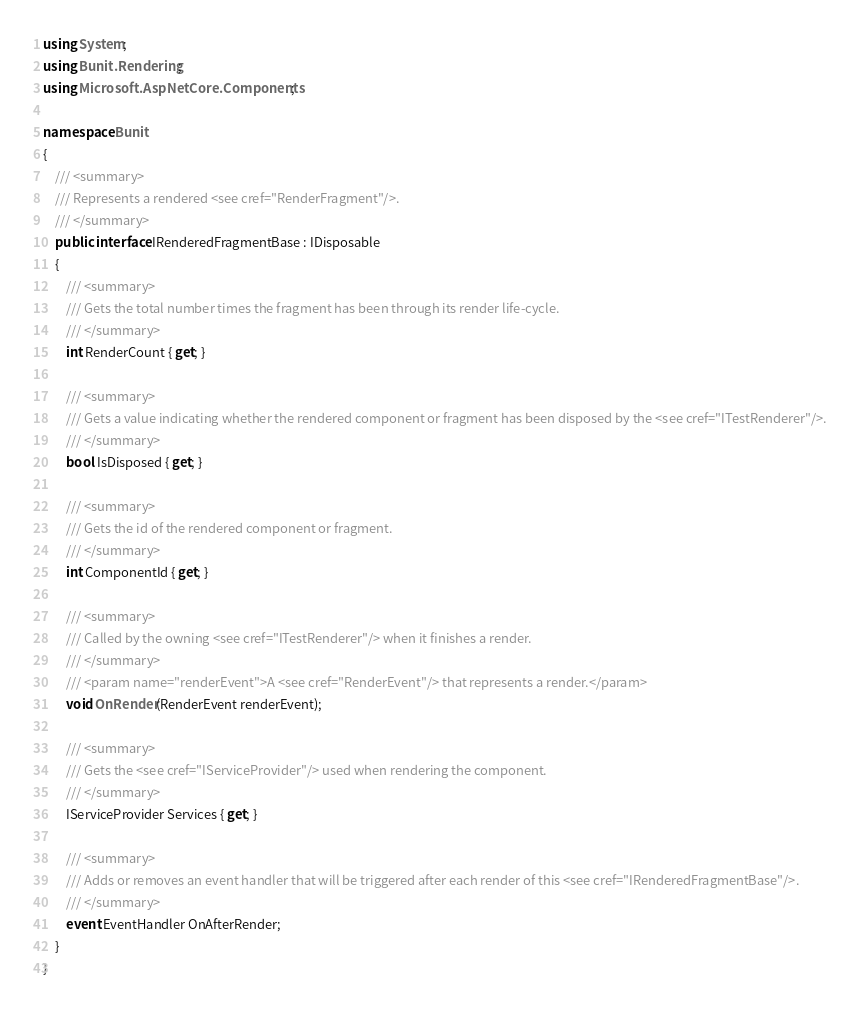<code> <loc_0><loc_0><loc_500><loc_500><_C#_>using System;
using Bunit.Rendering;
using Microsoft.AspNetCore.Components;

namespace Bunit
{
	/// <summary>
	/// Represents a rendered <see cref="RenderFragment"/>.
	/// </summary>
	public interface IRenderedFragmentBase : IDisposable
	{
		/// <summary>
		/// Gets the total number times the fragment has been through its render life-cycle.
		/// </summary>
		int RenderCount { get; }

		/// <summary>
		/// Gets a value indicating whether the rendered component or fragment has been disposed by the <see cref="ITestRenderer"/>.
		/// </summary>
		bool IsDisposed { get; }

		/// <summary>
		/// Gets the id of the rendered component or fragment.
		/// </summary>
		int ComponentId { get; }

		/// <summary>
		/// Called by the owning <see cref="ITestRenderer"/> when it finishes a render.
		/// </summary>
		/// <param name="renderEvent">A <see cref="RenderEvent"/> that represents a render.</param>
		void OnRender(RenderEvent renderEvent);

		/// <summary>
		/// Gets the <see cref="IServiceProvider"/> used when rendering the component.
		/// </summary>
		IServiceProvider Services { get; }

		/// <summary>
		/// Adds or removes an event handler that will be triggered after each render of this <see cref="IRenderedFragmentBase"/>.
		/// </summary>
		event EventHandler OnAfterRender;
	}
}
</code> 